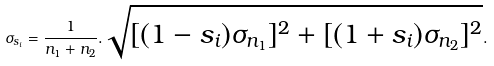Convert formula to latex. <formula><loc_0><loc_0><loc_500><loc_500>\sigma _ { s _ { i } } = \frac { 1 } { n _ { 1 } + n _ { 2 } } . \sqrt { [ ( 1 - s _ { i } ) \sigma _ { { n } _ { 1 } } ] ^ { 2 } + [ ( 1 + s _ { i } ) \sigma _ { { n } _ { 2 } } ] ^ { 2 } } .</formula> 